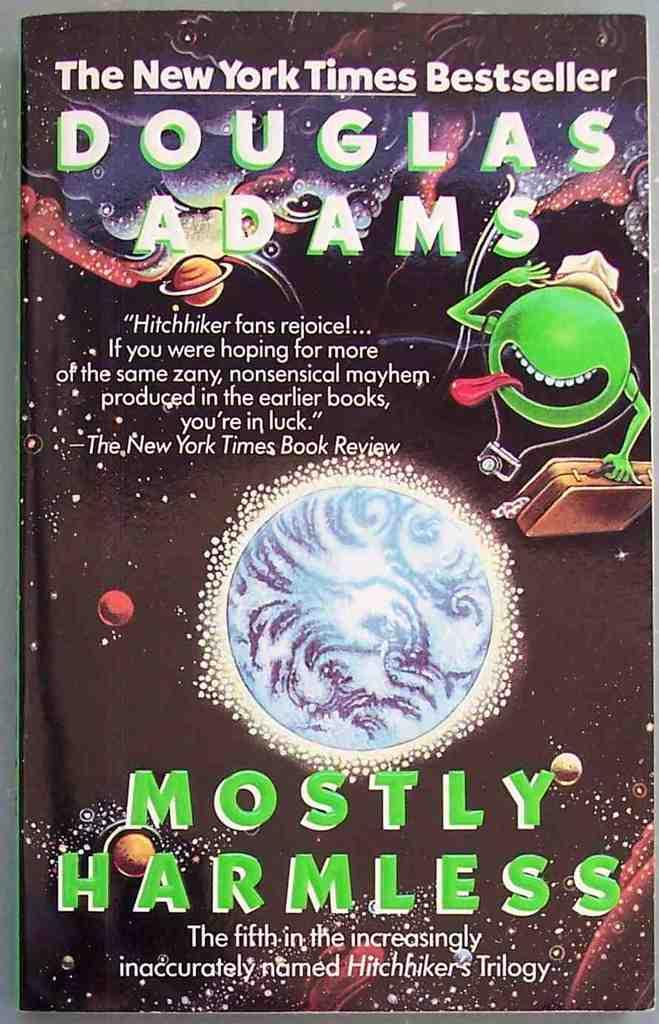<image>
Write a terse but informative summary of the picture. the cover of the book titled Mostly harmless by douglas adams. 